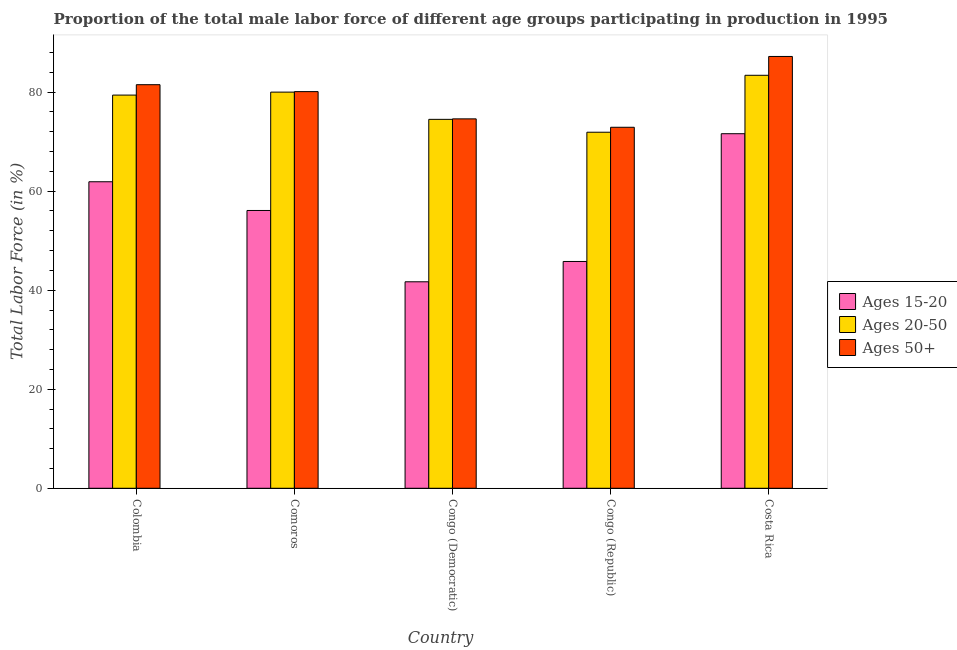How many different coloured bars are there?
Offer a terse response. 3. How many groups of bars are there?
Your answer should be compact. 5. Are the number of bars on each tick of the X-axis equal?
Offer a very short reply. Yes. How many bars are there on the 4th tick from the left?
Offer a terse response. 3. What is the label of the 2nd group of bars from the left?
Make the answer very short. Comoros. What is the percentage of male labor force within the age group 20-50 in Congo (Republic)?
Give a very brief answer. 71.9. Across all countries, what is the maximum percentage of male labor force within the age group 20-50?
Make the answer very short. 83.4. Across all countries, what is the minimum percentage of male labor force within the age group 20-50?
Provide a short and direct response. 71.9. In which country was the percentage of male labor force within the age group 15-20 maximum?
Keep it short and to the point. Costa Rica. In which country was the percentage of male labor force within the age group 20-50 minimum?
Keep it short and to the point. Congo (Republic). What is the total percentage of male labor force within the age group 15-20 in the graph?
Offer a very short reply. 277.1. What is the difference between the percentage of male labor force within the age group 15-20 in Congo (Democratic) and that in Costa Rica?
Offer a very short reply. -29.9. What is the difference between the percentage of male labor force within the age group 20-50 in Costa Rica and the percentage of male labor force above age 50 in Colombia?
Your answer should be compact. 1.9. What is the average percentage of male labor force within the age group 20-50 per country?
Offer a terse response. 77.84. What is the difference between the percentage of male labor force above age 50 and percentage of male labor force within the age group 15-20 in Comoros?
Your answer should be very brief. 24. What is the ratio of the percentage of male labor force above age 50 in Congo (Democratic) to that in Congo (Republic)?
Give a very brief answer. 1.02. Is the difference between the percentage of male labor force above age 50 in Comoros and Congo (Democratic) greater than the difference between the percentage of male labor force within the age group 20-50 in Comoros and Congo (Democratic)?
Your answer should be very brief. No. What is the difference between the highest and the second highest percentage of male labor force above age 50?
Ensure brevity in your answer.  5.7. What is the difference between the highest and the lowest percentage of male labor force within the age group 20-50?
Make the answer very short. 11.5. In how many countries, is the percentage of male labor force within the age group 15-20 greater than the average percentage of male labor force within the age group 15-20 taken over all countries?
Give a very brief answer. 3. What does the 3rd bar from the left in Congo (Republic) represents?
Your answer should be compact. Ages 50+. What does the 1st bar from the right in Congo (Republic) represents?
Make the answer very short. Ages 50+. How many bars are there?
Provide a short and direct response. 15. What is the difference between two consecutive major ticks on the Y-axis?
Give a very brief answer. 20. What is the title of the graph?
Your answer should be compact. Proportion of the total male labor force of different age groups participating in production in 1995. What is the label or title of the Y-axis?
Offer a very short reply. Total Labor Force (in %). What is the Total Labor Force (in %) of Ages 15-20 in Colombia?
Provide a short and direct response. 61.9. What is the Total Labor Force (in %) in Ages 20-50 in Colombia?
Provide a short and direct response. 79.4. What is the Total Labor Force (in %) in Ages 50+ in Colombia?
Offer a terse response. 81.5. What is the Total Labor Force (in %) in Ages 15-20 in Comoros?
Offer a very short reply. 56.1. What is the Total Labor Force (in %) of Ages 20-50 in Comoros?
Ensure brevity in your answer.  80. What is the Total Labor Force (in %) of Ages 50+ in Comoros?
Your answer should be very brief. 80.1. What is the Total Labor Force (in %) of Ages 15-20 in Congo (Democratic)?
Your answer should be compact. 41.7. What is the Total Labor Force (in %) in Ages 20-50 in Congo (Democratic)?
Your answer should be compact. 74.5. What is the Total Labor Force (in %) of Ages 50+ in Congo (Democratic)?
Your answer should be compact. 74.6. What is the Total Labor Force (in %) in Ages 15-20 in Congo (Republic)?
Ensure brevity in your answer.  45.8. What is the Total Labor Force (in %) of Ages 20-50 in Congo (Republic)?
Offer a terse response. 71.9. What is the Total Labor Force (in %) in Ages 50+ in Congo (Republic)?
Your response must be concise. 72.9. What is the Total Labor Force (in %) of Ages 15-20 in Costa Rica?
Provide a succinct answer. 71.6. What is the Total Labor Force (in %) in Ages 20-50 in Costa Rica?
Your answer should be very brief. 83.4. What is the Total Labor Force (in %) in Ages 50+ in Costa Rica?
Your answer should be compact. 87.2. Across all countries, what is the maximum Total Labor Force (in %) in Ages 15-20?
Provide a short and direct response. 71.6. Across all countries, what is the maximum Total Labor Force (in %) of Ages 20-50?
Your answer should be very brief. 83.4. Across all countries, what is the maximum Total Labor Force (in %) in Ages 50+?
Make the answer very short. 87.2. Across all countries, what is the minimum Total Labor Force (in %) of Ages 15-20?
Provide a succinct answer. 41.7. Across all countries, what is the minimum Total Labor Force (in %) of Ages 20-50?
Provide a short and direct response. 71.9. Across all countries, what is the minimum Total Labor Force (in %) in Ages 50+?
Keep it short and to the point. 72.9. What is the total Total Labor Force (in %) in Ages 15-20 in the graph?
Offer a terse response. 277.1. What is the total Total Labor Force (in %) of Ages 20-50 in the graph?
Offer a terse response. 389.2. What is the total Total Labor Force (in %) in Ages 50+ in the graph?
Your response must be concise. 396.3. What is the difference between the Total Labor Force (in %) in Ages 15-20 in Colombia and that in Comoros?
Make the answer very short. 5.8. What is the difference between the Total Labor Force (in %) in Ages 50+ in Colombia and that in Comoros?
Make the answer very short. 1.4. What is the difference between the Total Labor Force (in %) in Ages 15-20 in Colombia and that in Congo (Democratic)?
Your answer should be very brief. 20.2. What is the difference between the Total Labor Force (in %) of Ages 20-50 in Colombia and that in Congo (Republic)?
Your answer should be compact. 7.5. What is the difference between the Total Labor Force (in %) of Ages 50+ in Colombia and that in Congo (Republic)?
Ensure brevity in your answer.  8.6. What is the difference between the Total Labor Force (in %) of Ages 15-20 in Colombia and that in Costa Rica?
Give a very brief answer. -9.7. What is the difference between the Total Labor Force (in %) of Ages 50+ in Colombia and that in Costa Rica?
Offer a terse response. -5.7. What is the difference between the Total Labor Force (in %) in Ages 50+ in Comoros and that in Congo (Democratic)?
Provide a short and direct response. 5.5. What is the difference between the Total Labor Force (in %) in Ages 15-20 in Comoros and that in Congo (Republic)?
Your response must be concise. 10.3. What is the difference between the Total Labor Force (in %) in Ages 20-50 in Comoros and that in Congo (Republic)?
Your response must be concise. 8.1. What is the difference between the Total Labor Force (in %) in Ages 15-20 in Comoros and that in Costa Rica?
Provide a short and direct response. -15.5. What is the difference between the Total Labor Force (in %) of Ages 15-20 in Congo (Democratic) and that in Congo (Republic)?
Provide a succinct answer. -4.1. What is the difference between the Total Labor Force (in %) of Ages 20-50 in Congo (Democratic) and that in Congo (Republic)?
Provide a succinct answer. 2.6. What is the difference between the Total Labor Force (in %) in Ages 50+ in Congo (Democratic) and that in Congo (Republic)?
Provide a succinct answer. 1.7. What is the difference between the Total Labor Force (in %) in Ages 15-20 in Congo (Democratic) and that in Costa Rica?
Keep it short and to the point. -29.9. What is the difference between the Total Labor Force (in %) of Ages 20-50 in Congo (Democratic) and that in Costa Rica?
Offer a terse response. -8.9. What is the difference between the Total Labor Force (in %) in Ages 15-20 in Congo (Republic) and that in Costa Rica?
Your answer should be compact. -25.8. What is the difference between the Total Labor Force (in %) in Ages 20-50 in Congo (Republic) and that in Costa Rica?
Ensure brevity in your answer.  -11.5. What is the difference between the Total Labor Force (in %) in Ages 50+ in Congo (Republic) and that in Costa Rica?
Keep it short and to the point. -14.3. What is the difference between the Total Labor Force (in %) in Ages 15-20 in Colombia and the Total Labor Force (in %) in Ages 20-50 in Comoros?
Ensure brevity in your answer.  -18.1. What is the difference between the Total Labor Force (in %) of Ages 15-20 in Colombia and the Total Labor Force (in %) of Ages 50+ in Comoros?
Your answer should be compact. -18.2. What is the difference between the Total Labor Force (in %) of Ages 20-50 in Colombia and the Total Labor Force (in %) of Ages 50+ in Comoros?
Offer a terse response. -0.7. What is the difference between the Total Labor Force (in %) of Ages 15-20 in Colombia and the Total Labor Force (in %) of Ages 20-50 in Congo (Democratic)?
Keep it short and to the point. -12.6. What is the difference between the Total Labor Force (in %) in Ages 15-20 in Colombia and the Total Labor Force (in %) in Ages 20-50 in Congo (Republic)?
Provide a short and direct response. -10. What is the difference between the Total Labor Force (in %) of Ages 15-20 in Colombia and the Total Labor Force (in %) of Ages 50+ in Congo (Republic)?
Give a very brief answer. -11. What is the difference between the Total Labor Force (in %) of Ages 20-50 in Colombia and the Total Labor Force (in %) of Ages 50+ in Congo (Republic)?
Your answer should be very brief. 6.5. What is the difference between the Total Labor Force (in %) of Ages 15-20 in Colombia and the Total Labor Force (in %) of Ages 20-50 in Costa Rica?
Your answer should be very brief. -21.5. What is the difference between the Total Labor Force (in %) in Ages 15-20 in Colombia and the Total Labor Force (in %) in Ages 50+ in Costa Rica?
Your response must be concise. -25.3. What is the difference between the Total Labor Force (in %) of Ages 20-50 in Colombia and the Total Labor Force (in %) of Ages 50+ in Costa Rica?
Offer a very short reply. -7.8. What is the difference between the Total Labor Force (in %) in Ages 15-20 in Comoros and the Total Labor Force (in %) in Ages 20-50 in Congo (Democratic)?
Offer a very short reply. -18.4. What is the difference between the Total Labor Force (in %) in Ages 15-20 in Comoros and the Total Labor Force (in %) in Ages 50+ in Congo (Democratic)?
Give a very brief answer. -18.5. What is the difference between the Total Labor Force (in %) in Ages 20-50 in Comoros and the Total Labor Force (in %) in Ages 50+ in Congo (Democratic)?
Your answer should be compact. 5.4. What is the difference between the Total Labor Force (in %) in Ages 15-20 in Comoros and the Total Labor Force (in %) in Ages 20-50 in Congo (Republic)?
Your answer should be very brief. -15.8. What is the difference between the Total Labor Force (in %) in Ages 15-20 in Comoros and the Total Labor Force (in %) in Ages 50+ in Congo (Republic)?
Offer a very short reply. -16.8. What is the difference between the Total Labor Force (in %) of Ages 20-50 in Comoros and the Total Labor Force (in %) of Ages 50+ in Congo (Republic)?
Provide a short and direct response. 7.1. What is the difference between the Total Labor Force (in %) of Ages 15-20 in Comoros and the Total Labor Force (in %) of Ages 20-50 in Costa Rica?
Your response must be concise. -27.3. What is the difference between the Total Labor Force (in %) in Ages 15-20 in Comoros and the Total Labor Force (in %) in Ages 50+ in Costa Rica?
Your answer should be compact. -31.1. What is the difference between the Total Labor Force (in %) of Ages 15-20 in Congo (Democratic) and the Total Labor Force (in %) of Ages 20-50 in Congo (Republic)?
Provide a succinct answer. -30.2. What is the difference between the Total Labor Force (in %) of Ages 15-20 in Congo (Democratic) and the Total Labor Force (in %) of Ages 50+ in Congo (Republic)?
Your answer should be compact. -31.2. What is the difference between the Total Labor Force (in %) in Ages 20-50 in Congo (Democratic) and the Total Labor Force (in %) in Ages 50+ in Congo (Republic)?
Your answer should be very brief. 1.6. What is the difference between the Total Labor Force (in %) of Ages 15-20 in Congo (Democratic) and the Total Labor Force (in %) of Ages 20-50 in Costa Rica?
Make the answer very short. -41.7. What is the difference between the Total Labor Force (in %) in Ages 15-20 in Congo (Democratic) and the Total Labor Force (in %) in Ages 50+ in Costa Rica?
Your response must be concise. -45.5. What is the difference between the Total Labor Force (in %) of Ages 20-50 in Congo (Democratic) and the Total Labor Force (in %) of Ages 50+ in Costa Rica?
Your response must be concise. -12.7. What is the difference between the Total Labor Force (in %) of Ages 15-20 in Congo (Republic) and the Total Labor Force (in %) of Ages 20-50 in Costa Rica?
Your response must be concise. -37.6. What is the difference between the Total Labor Force (in %) in Ages 15-20 in Congo (Republic) and the Total Labor Force (in %) in Ages 50+ in Costa Rica?
Make the answer very short. -41.4. What is the difference between the Total Labor Force (in %) in Ages 20-50 in Congo (Republic) and the Total Labor Force (in %) in Ages 50+ in Costa Rica?
Give a very brief answer. -15.3. What is the average Total Labor Force (in %) in Ages 15-20 per country?
Provide a short and direct response. 55.42. What is the average Total Labor Force (in %) in Ages 20-50 per country?
Provide a succinct answer. 77.84. What is the average Total Labor Force (in %) of Ages 50+ per country?
Provide a short and direct response. 79.26. What is the difference between the Total Labor Force (in %) of Ages 15-20 and Total Labor Force (in %) of Ages 20-50 in Colombia?
Provide a succinct answer. -17.5. What is the difference between the Total Labor Force (in %) in Ages 15-20 and Total Labor Force (in %) in Ages 50+ in Colombia?
Offer a terse response. -19.6. What is the difference between the Total Labor Force (in %) of Ages 15-20 and Total Labor Force (in %) of Ages 20-50 in Comoros?
Your answer should be compact. -23.9. What is the difference between the Total Labor Force (in %) of Ages 15-20 and Total Labor Force (in %) of Ages 20-50 in Congo (Democratic)?
Your response must be concise. -32.8. What is the difference between the Total Labor Force (in %) in Ages 15-20 and Total Labor Force (in %) in Ages 50+ in Congo (Democratic)?
Ensure brevity in your answer.  -32.9. What is the difference between the Total Labor Force (in %) of Ages 20-50 and Total Labor Force (in %) of Ages 50+ in Congo (Democratic)?
Your answer should be compact. -0.1. What is the difference between the Total Labor Force (in %) in Ages 15-20 and Total Labor Force (in %) in Ages 20-50 in Congo (Republic)?
Make the answer very short. -26.1. What is the difference between the Total Labor Force (in %) of Ages 15-20 and Total Labor Force (in %) of Ages 50+ in Congo (Republic)?
Make the answer very short. -27.1. What is the difference between the Total Labor Force (in %) in Ages 20-50 and Total Labor Force (in %) in Ages 50+ in Congo (Republic)?
Provide a short and direct response. -1. What is the difference between the Total Labor Force (in %) in Ages 15-20 and Total Labor Force (in %) in Ages 20-50 in Costa Rica?
Offer a terse response. -11.8. What is the difference between the Total Labor Force (in %) of Ages 15-20 and Total Labor Force (in %) of Ages 50+ in Costa Rica?
Make the answer very short. -15.6. What is the difference between the Total Labor Force (in %) in Ages 20-50 and Total Labor Force (in %) in Ages 50+ in Costa Rica?
Keep it short and to the point. -3.8. What is the ratio of the Total Labor Force (in %) in Ages 15-20 in Colombia to that in Comoros?
Provide a short and direct response. 1.1. What is the ratio of the Total Labor Force (in %) of Ages 50+ in Colombia to that in Comoros?
Offer a very short reply. 1.02. What is the ratio of the Total Labor Force (in %) in Ages 15-20 in Colombia to that in Congo (Democratic)?
Give a very brief answer. 1.48. What is the ratio of the Total Labor Force (in %) of Ages 20-50 in Colombia to that in Congo (Democratic)?
Ensure brevity in your answer.  1.07. What is the ratio of the Total Labor Force (in %) in Ages 50+ in Colombia to that in Congo (Democratic)?
Provide a short and direct response. 1.09. What is the ratio of the Total Labor Force (in %) in Ages 15-20 in Colombia to that in Congo (Republic)?
Make the answer very short. 1.35. What is the ratio of the Total Labor Force (in %) in Ages 20-50 in Colombia to that in Congo (Republic)?
Keep it short and to the point. 1.1. What is the ratio of the Total Labor Force (in %) in Ages 50+ in Colombia to that in Congo (Republic)?
Provide a short and direct response. 1.12. What is the ratio of the Total Labor Force (in %) in Ages 15-20 in Colombia to that in Costa Rica?
Offer a terse response. 0.86. What is the ratio of the Total Labor Force (in %) in Ages 20-50 in Colombia to that in Costa Rica?
Ensure brevity in your answer.  0.95. What is the ratio of the Total Labor Force (in %) in Ages 50+ in Colombia to that in Costa Rica?
Keep it short and to the point. 0.93. What is the ratio of the Total Labor Force (in %) in Ages 15-20 in Comoros to that in Congo (Democratic)?
Offer a terse response. 1.35. What is the ratio of the Total Labor Force (in %) of Ages 20-50 in Comoros to that in Congo (Democratic)?
Provide a succinct answer. 1.07. What is the ratio of the Total Labor Force (in %) in Ages 50+ in Comoros to that in Congo (Democratic)?
Make the answer very short. 1.07. What is the ratio of the Total Labor Force (in %) of Ages 15-20 in Comoros to that in Congo (Republic)?
Provide a succinct answer. 1.22. What is the ratio of the Total Labor Force (in %) in Ages 20-50 in Comoros to that in Congo (Republic)?
Your response must be concise. 1.11. What is the ratio of the Total Labor Force (in %) in Ages 50+ in Comoros to that in Congo (Republic)?
Offer a very short reply. 1.1. What is the ratio of the Total Labor Force (in %) in Ages 15-20 in Comoros to that in Costa Rica?
Keep it short and to the point. 0.78. What is the ratio of the Total Labor Force (in %) of Ages 20-50 in Comoros to that in Costa Rica?
Offer a terse response. 0.96. What is the ratio of the Total Labor Force (in %) of Ages 50+ in Comoros to that in Costa Rica?
Keep it short and to the point. 0.92. What is the ratio of the Total Labor Force (in %) of Ages 15-20 in Congo (Democratic) to that in Congo (Republic)?
Make the answer very short. 0.91. What is the ratio of the Total Labor Force (in %) of Ages 20-50 in Congo (Democratic) to that in Congo (Republic)?
Offer a terse response. 1.04. What is the ratio of the Total Labor Force (in %) of Ages 50+ in Congo (Democratic) to that in Congo (Republic)?
Offer a very short reply. 1.02. What is the ratio of the Total Labor Force (in %) in Ages 15-20 in Congo (Democratic) to that in Costa Rica?
Offer a very short reply. 0.58. What is the ratio of the Total Labor Force (in %) in Ages 20-50 in Congo (Democratic) to that in Costa Rica?
Your answer should be very brief. 0.89. What is the ratio of the Total Labor Force (in %) of Ages 50+ in Congo (Democratic) to that in Costa Rica?
Provide a succinct answer. 0.86. What is the ratio of the Total Labor Force (in %) of Ages 15-20 in Congo (Republic) to that in Costa Rica?
Your answer should be very brief. 0.64. What is the ratio of the Total Labor Force (in %) in Ages 20-50 in Congo (Republic) to that in Costa Rica?
Offer a very short reply. 0.86. What is the ratio of the Total Labor Force (in %) in Ages 50+ in Congo (Republic) to that in Costa Rica?
Make the answer very short. 0.84. What is the difference between the highest and the second highest Total Labor Force (in %) of Ages 15-20?
Provide a succinct answer. 9.7. What is the difference between the highest and the second highest Total Labor Force (in %) in Ages 20-50?
Your answer should be compact. 3.4. What is the difference between the highest and the lowest Total Labor Force (in %) in Ages 15-20?
Make the answer very short. 29.9. 